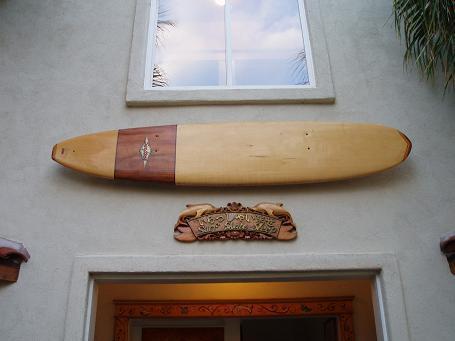How many surfboards are in the picture?
Give a very brief answer. 1. 